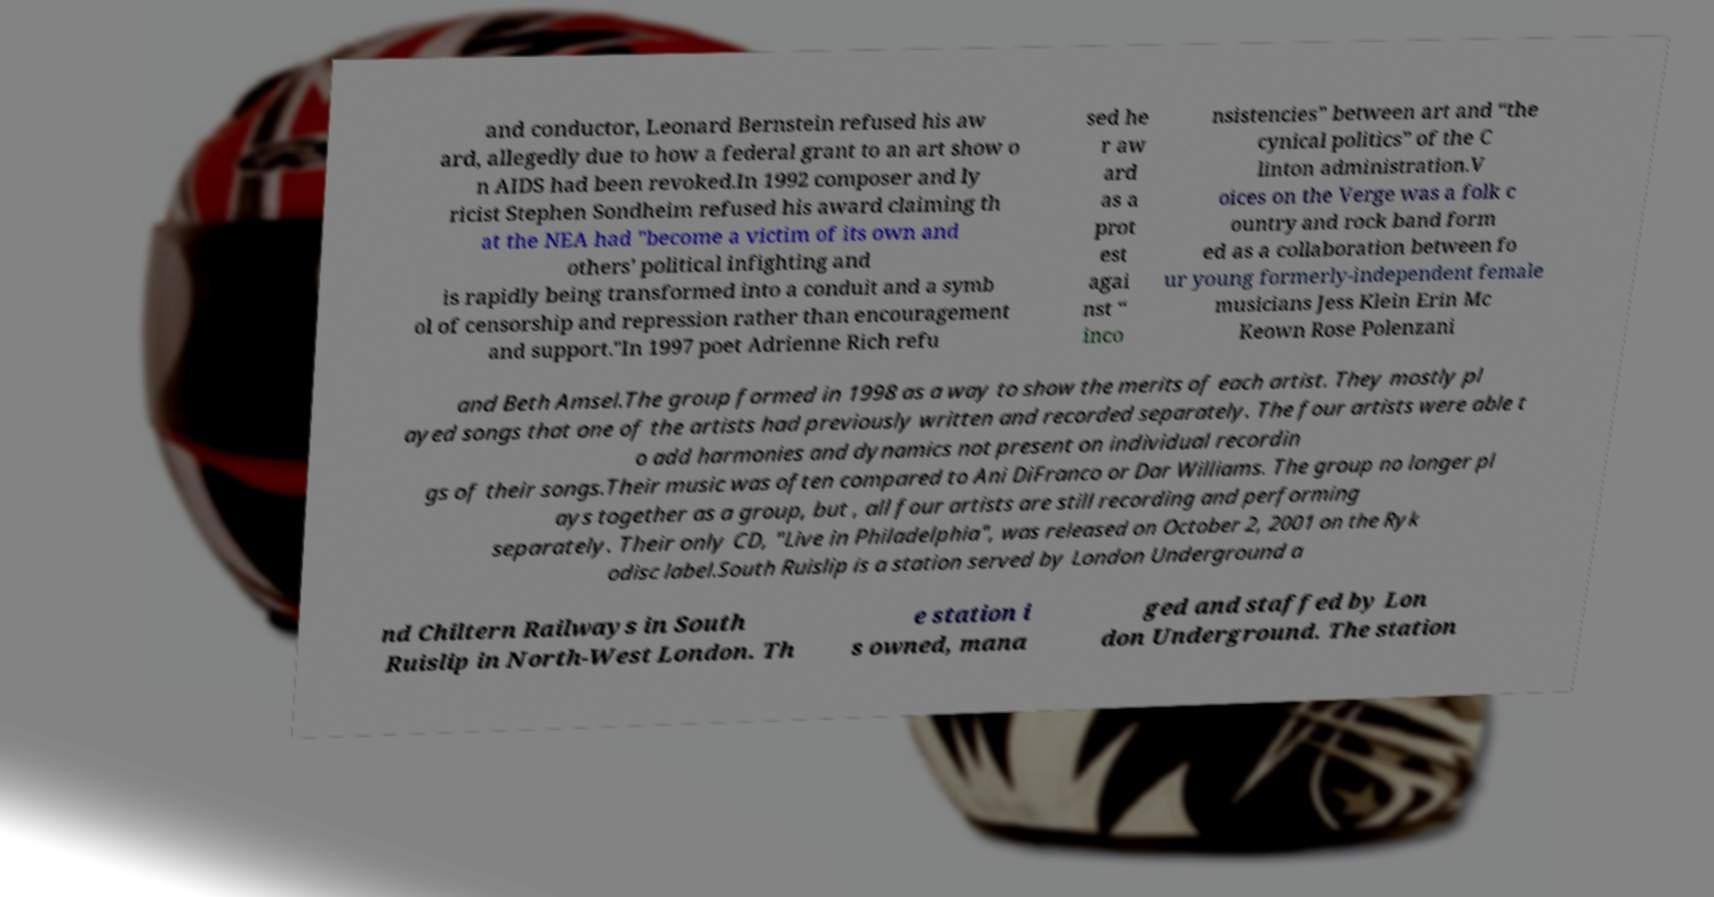There's text embedded in this image that I need extracted. Can you transcribe it verbatim? and conductor, Leonard Bernstein refused his aw ard, allegedly due to how a federal grant to an art show o n AIDS had been revoked.In 1992 composer and ly ricist Stephen Sondheim refused his award claiming th at the NEA had "become a victim of its own and others' political infighting and is rapidly being transformed into a conduit and a symb ol of censorship and repression rather than encouragement and support."In 1997 poet Adrienne Rich refu sed he r aw ard as a prot est agai nst “ inco nsistencies” between art and “the cynical politics” of the C linton administration.V oices on the Verge was a folk c ountry and rock band form ed as a collaboration between fo ur young formerly-independent female musicians Jess Klein Erin Mc Keown Rose Polenzani and Beth Amsel.The group formed in 1998 as a way to show the merits of each artist. They mostly pl ayed songs that one of the artists had previously written and recorded separately. The four artists were able t o add harmonies and dynamics not present on individual recordin gs of their songs.Their music was often compared to Ani DiFranco or Dar Williams. The group no longer pl ays together as a group, but , all four artists are still recording and performing separately. Their only CD, "Live in Philadelphia", was released on October 2, 2001 on the Ryk odisc label.South Ruislip is a station served by London Underground a nd Chiltern Railways in South Ruislip in North-West London. Th e station i s owned, mana ged and staffed by Lon don Underground. The station 